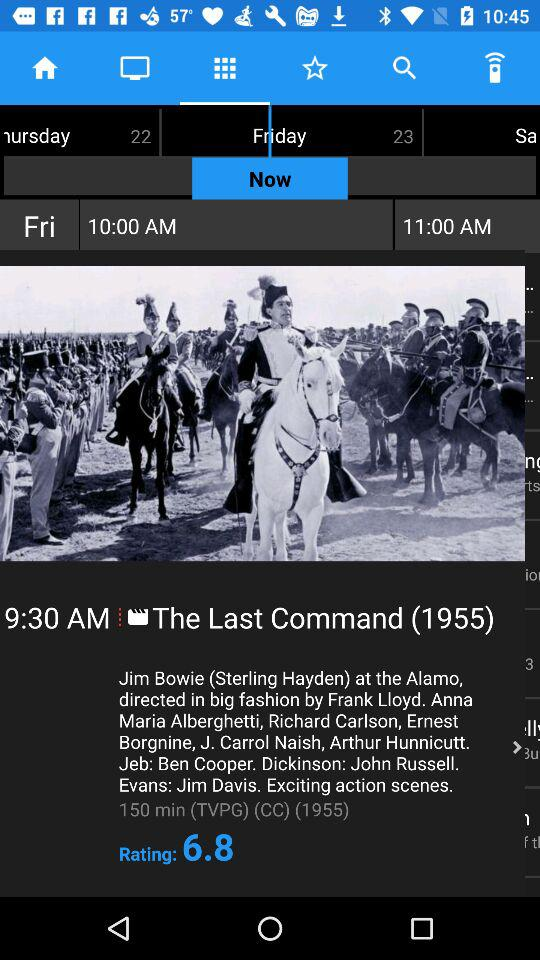What is the length of the movie? The length of the movie is 150 minutes. 